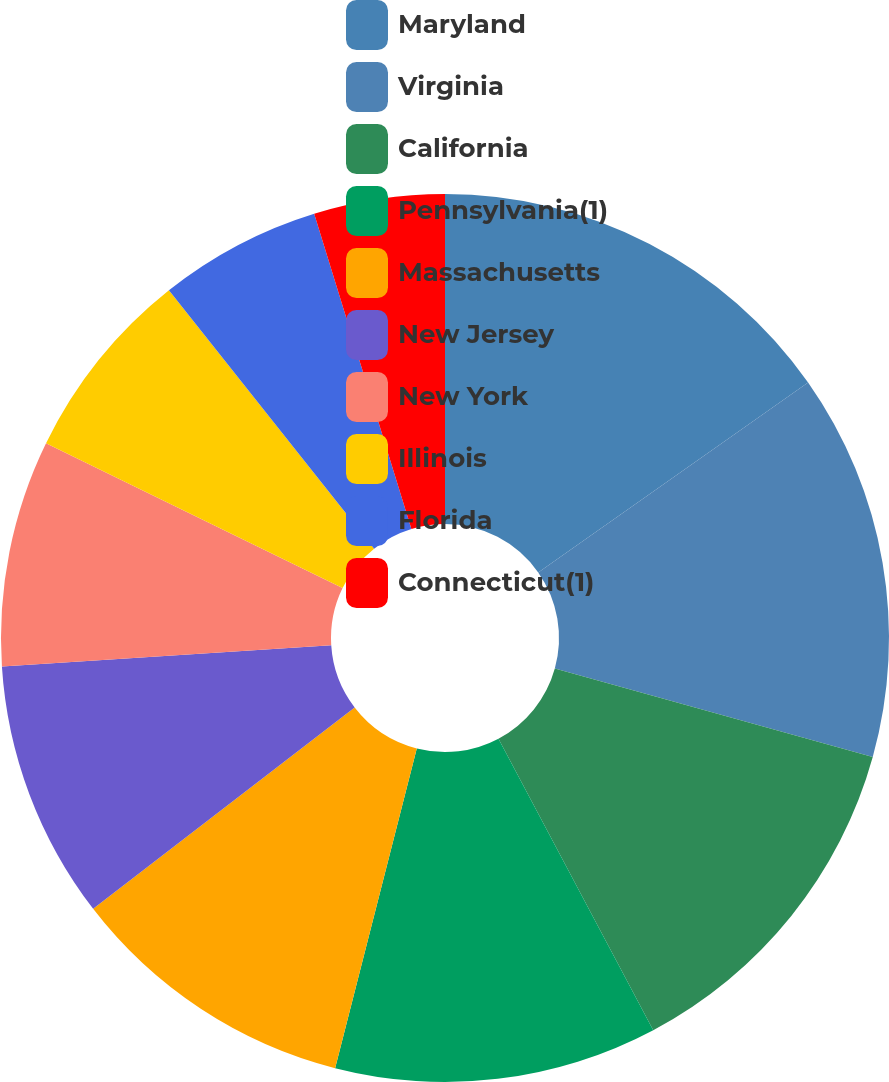Convert chart to OTSL. <chart><loc_0><loc_0><loc_500><loc_500><pie_chart><fcel>Maryland<fcel>Virginia<fcel>California<fcel>Pennsylvania(1)<fcel>Massachusetts<fcel>New Jersey<fcel>New York<fcel>Illinois<fcel>Florida<fcel>Connecticut(1)<nl><fcel>15.24%<fcel>14.08%<fcel>12.91%<fcel>11.75%<fcel>10.58%<fcel>9.42%<fcel>8.25%<fcel>7.09%<fcel>5.92%<fcel>4.76%<nl></chart> 